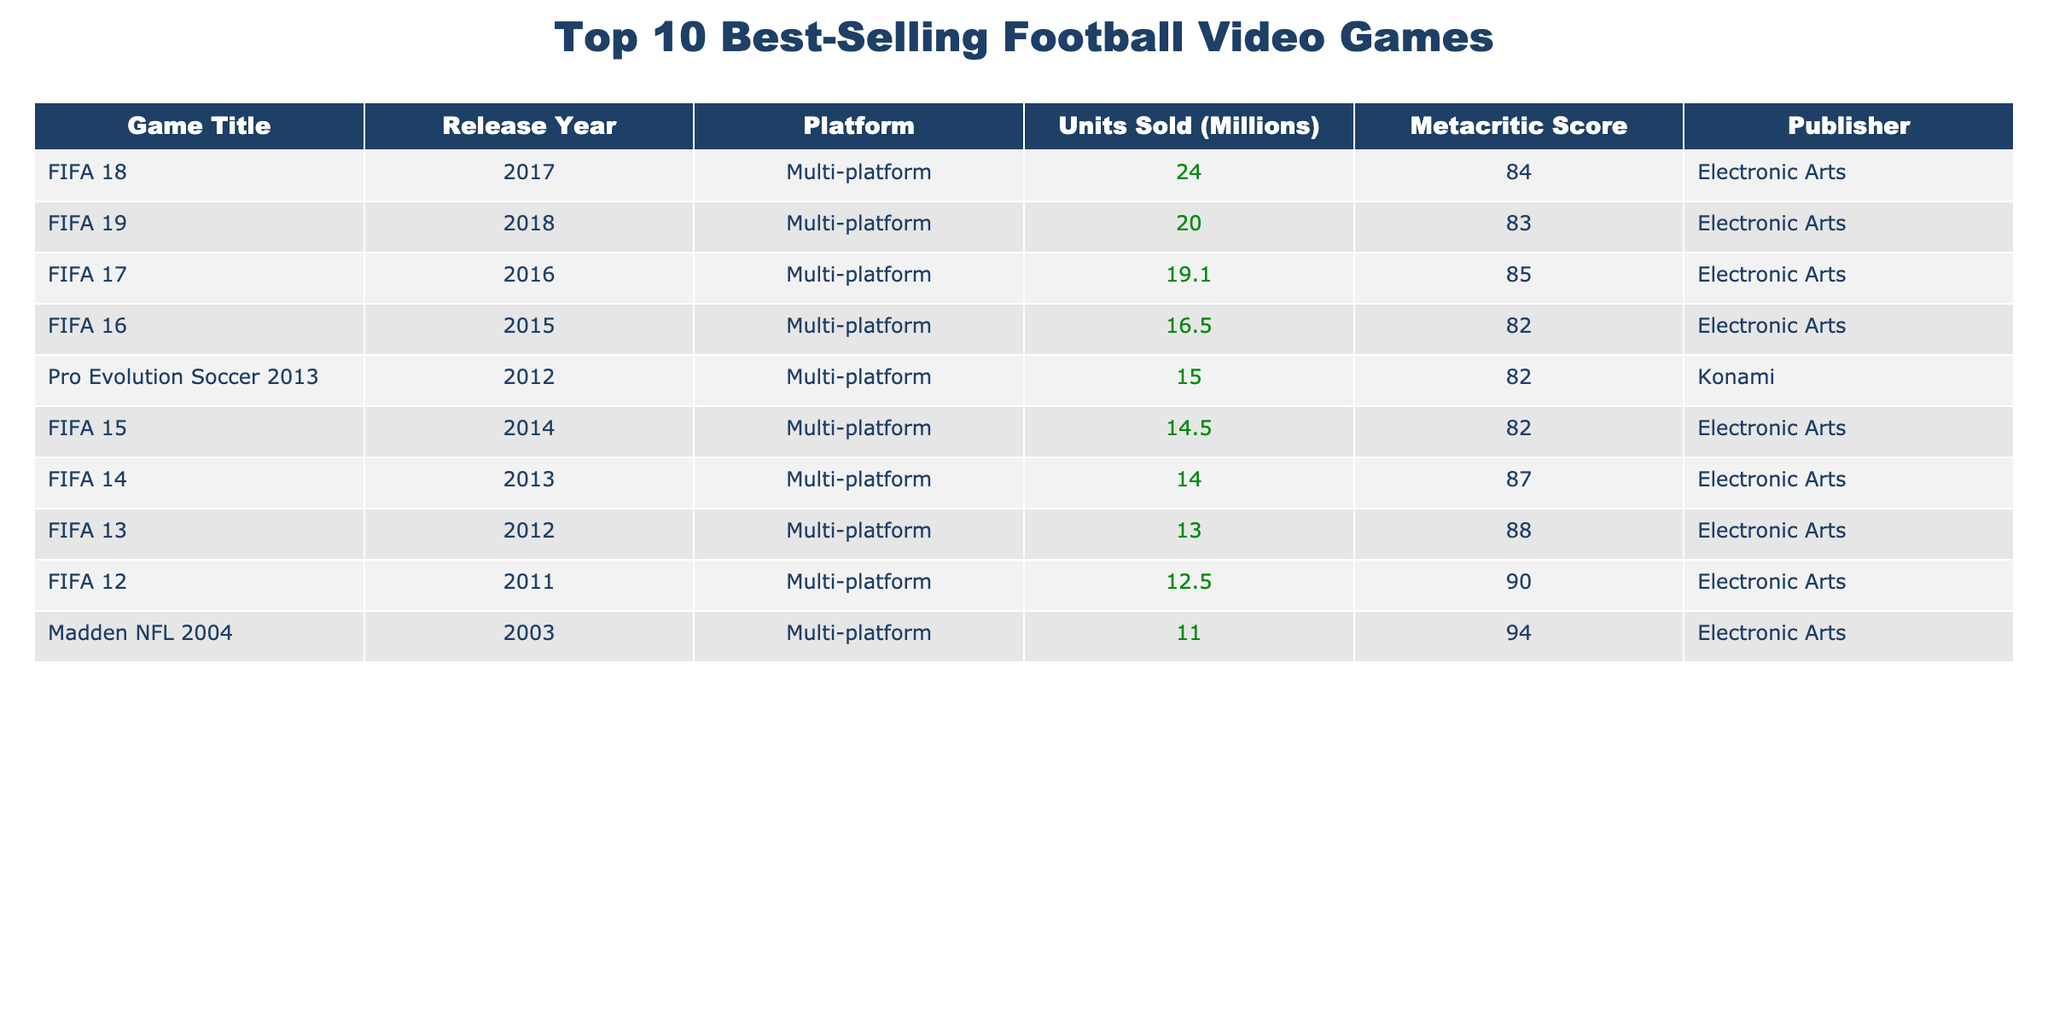What is the title of the best-selling football video game? The best-selling football video game, as indicated by the highest units sold in the table, is "FIFA 18" with 24 million units sold.
Answer: FIFA 18 How many units did "Pro Evolution Soccer 2013" sell? According to the table, "Pro Evolution Soccer 2013" sold 15 million units.
Answer: 15 million Which publisher has released the most games in the top 10 list? By counting the entries in the table, Electronic Arts has published 8 out of the 10 games listed, while Konami has published 1 game.
Answer: Electronic Arts What is the total number of units sold by all games in the table? To find the total, we sum the units sold: 24 + 20 + 19.1 + 16.5 + 15 + 14.5 + 14 + 13 + 12.5 + 11 =  24 + 20 + 19.1 + 16.5 + 15 + 14.5 + 14 + 13 + 12.5 + 11 =  24 + 20 = 44; 44 + 19.1 = 63.1; 63.1 + 16.5 = 79.6; 79.6 + 15 = 94.6; 94.6 + 14.5 = 109.1; 109.1 + 14 = 123.1; 123.1 + 13 = 136.1; 136.1 + 12.5 = 148.6; 148.6 + 11 = 159.6 million units.
Answer: 159.6 million Which game has the highest Metacritic score? "Madden NFL 2004" has the highest Metacritic score at 94, as seen in the table.
Answer: Madden NFL 2004 How many million units did the games released after 2015 sell in total? The games released after 2015 are FIFA 16, FIFA 17, FIFA 18, FIFA 19, and Pro Evolution Soccer 2013. Summing their units sold: 16.5 + 19.1 + 24.0 + 20.0 + 15 = 94.6 million units sold.
Answer: 94.6 million Is "FIFA 12" above or below the average units sold of all games? First, we calculate the average. The total units sold is 159.6 million, and there are 10 games, so the average is 159.6 / 10 = 15.96 million. "FIFA 12" sold 12.5 million, which is below the average of 15.96 million.
Answer: Below What is the difference in units sold between the highest and lowest-selling games? The highest-selling game is "FIFA 18" with 24 million units, and the lowest-selling game is "Madden NFL 2004" with 11 million units. The difference is 24 - 11 = 13 million units.
Answer: 13 million How many games had a Metacritic score of 85 or higher? There are four games ("FIFA 12", "FIFA 13", "FIFA 14", and "Madden NFL 2004") with a Metacritic score of 85 or higher.
Answer: 4 games Which FIFA title was released in 2016? The FIFA title released in 2016, as per the table, is "FIFA 17."
Answer: FIFA 17 